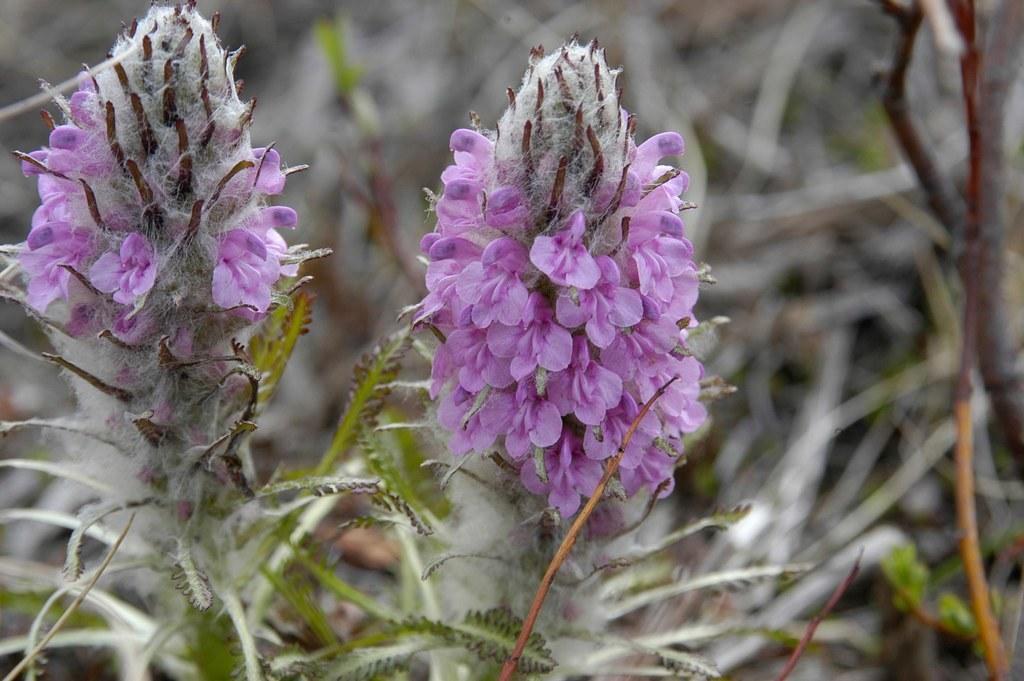Can you describe this image briefly? In this picture we can see few flowers and plants. 